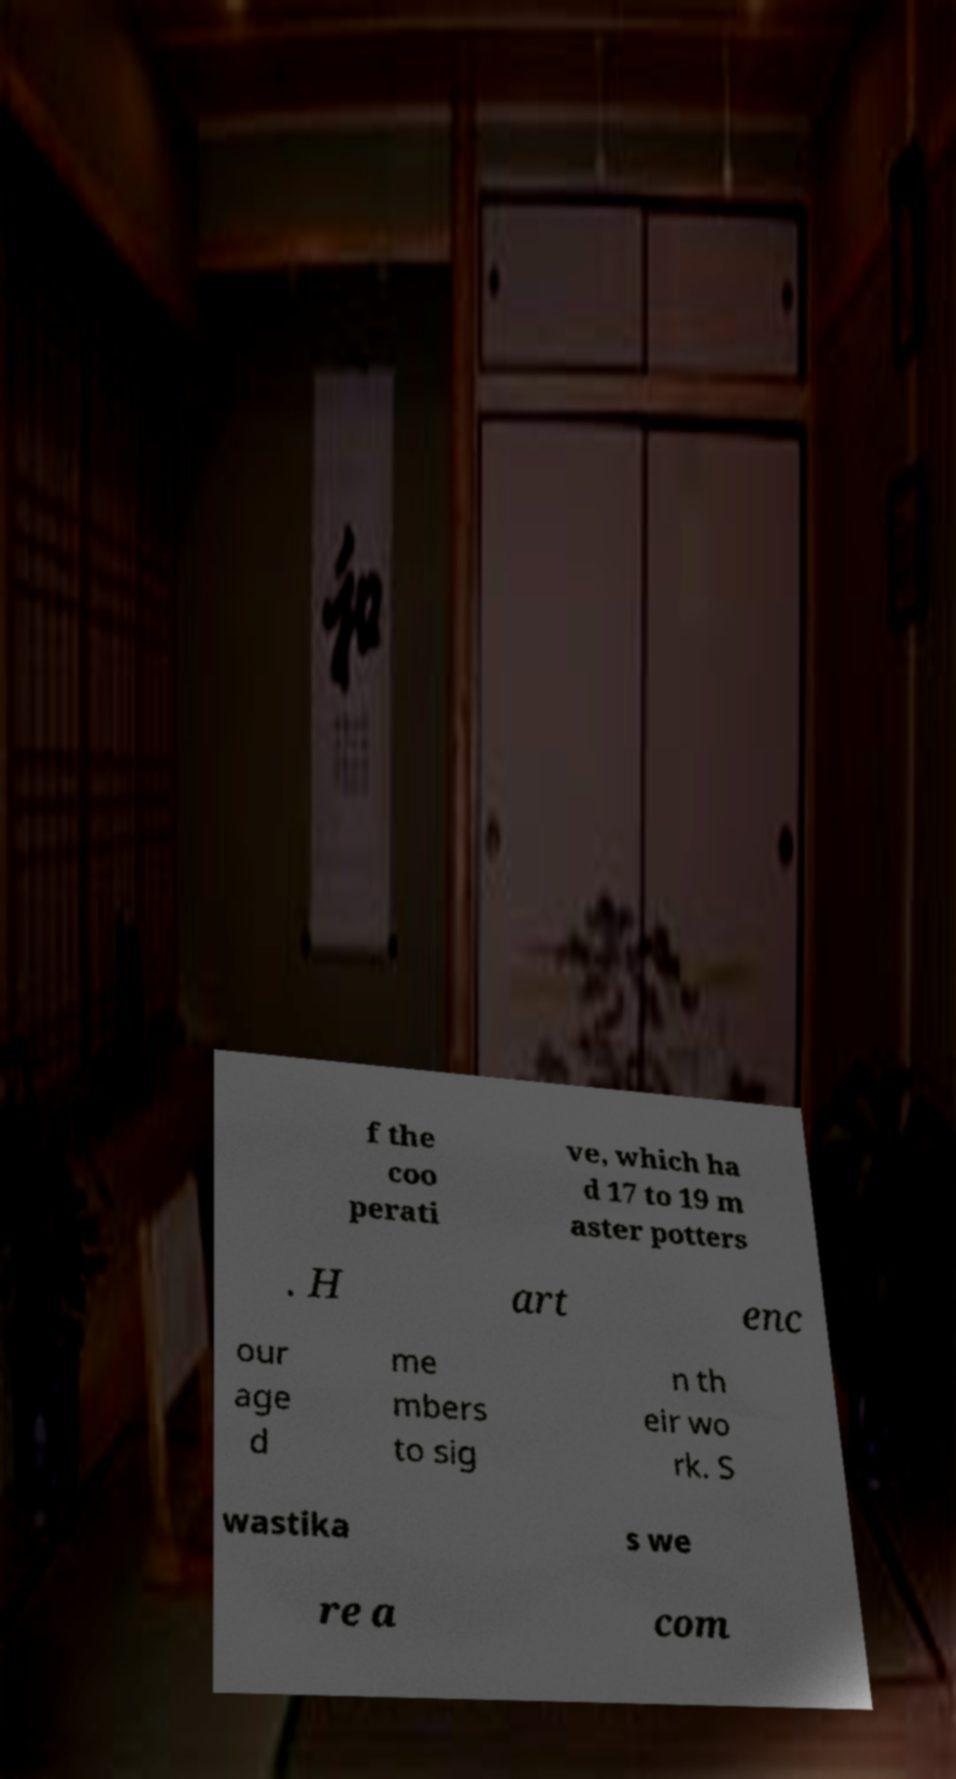Can you read and provide the text displayed in the image?This photo seems to have some interesting text. Can you extract and type it out for me? f the coo perati ve, which ha d 17 to 19 m aster potters . H art enc our age d me mbers to sig n th eir wo rk. S wastika s we re a com 